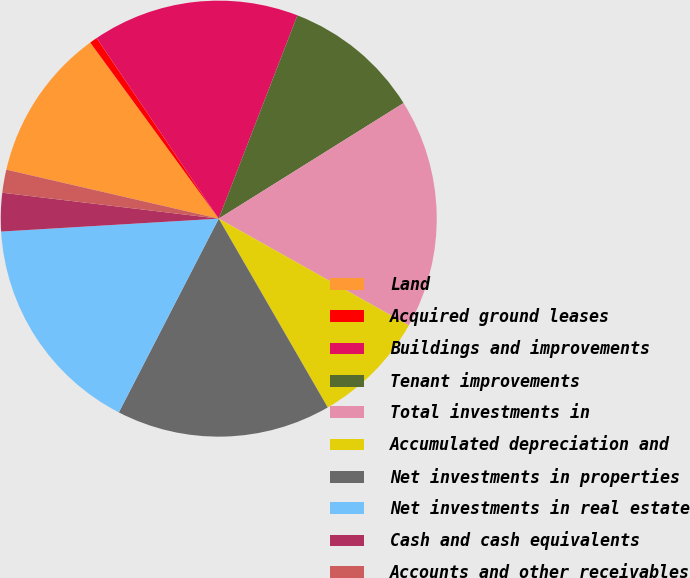Convert chart to OTSL. <chart><loc_0><loc_0><loc_500><loc_500><pie_chart><fcel>Land<fcel>Acquired ground leases<fcel>Buildings and improvements<fcel>Tenant improvements<fcel>Total investments in<fcel>Accumulated depreciation and<fcel>Net investments in properties<fcel>Net investments in real estate<fcel>Cash and cash equivalents<fcel>Accounts and other receivables<nl><fcel>11.36%<fcel>0.57%<fcel>15.34%<fcel>10.23%<fcel>17.04%<fcel>8.52%<fcel>15.91%<fcel>16.48%<fcel>2.84%<fcel>1.71%<nl></chart> 